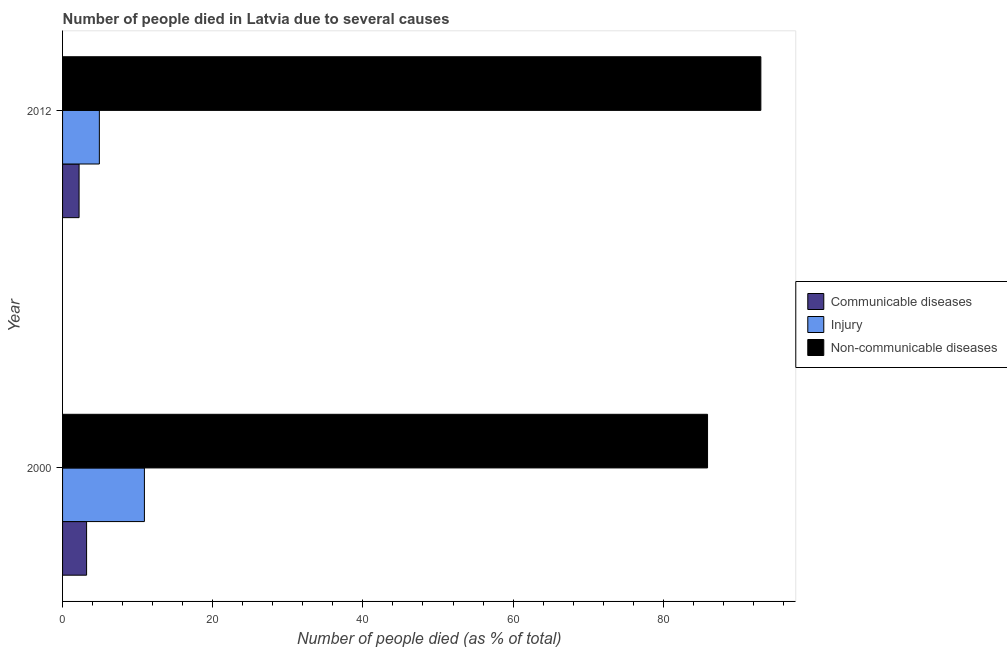Are the number of bars per tick equal to the number of legend labels?
Your answer should be compact. Yes. Are the number of bars on each tick of the Y-axis equal?
Keep it short and to the point. Yes. How many bars are there on the 1st tick from the top?
Your answer should be very brief. 3. In how many cases, is the number of bars for a given year not equal to the number of legend labels?
Provide a succinct answer. 0. What is the number of people who dies of non-communicable diseases in 2012?
Keep it short and to the point. 93. What is the total number of people who died of communicable diseases in the graph?
Provide a succinct answer. 5.4. What is the difference between the number of people who dies of non-communicable diseases in 2000 and the number of people who died of communicable diseases in 2012?
Provide a short and direct response. 83.7. What is the average number of people who dies of non-communicable diseases per year?
Your answer should be compact. 89.45. In the year 2012, what is the difference between the number of people who dies of non-communicable diseases and number of people who died of communicable diseases?
Offer a terse response. 90.8. What is the ratio of the number of people who dies of non-communicable diseases in 2000 to that in 2012?
Keep it short and to the point. 0.92. Is the difference between the number of people who died of communicable diseases in 2000 and 2012 greater than the difference between the number of people who died of injury in 2000 and 2012?
Your response must be concise. No. In how many years, is the number of people who died of communicable diseases greater than the average number of people who died of communicable diseases taken over all years?
Ensure brevity in your answer.  1. What does the 2nd bar from the top in 2000 represents?
Give a very brief answer. Injury. What does the 1st bar from the bottom in 2000 represents?
Offer a very short reply. Communicable diseases. How many years are there in the graph?
Make the answer very short. 2. What is the difference between two consecutive major ticks on the X-axis?
Your answer should be compact. 20. Are the values on the major ticks of X-axis written in scientific E-notation?
Ensure brevity in your answer.  No. Does the graph contain any zero values?
Provide a short and direct response. No. Does the graph contain grids?
Your response must be concise. No. How many legend labels are there?
Give a very brief answer. 3. What is the title of the graph?
Provide a succinct answer. Number of people died in Latvia due to several causes. Does "Czech Republic" appear as one of the legend labels in the graph?
Your answer should be compact. No. What is the label or title of the X-axis?
Offer a terse response. Number of people died (as % of total). What is the Number of people died (as % of total) in Communicable diseases in 2000?
Keep it short and to the point. 3.2. What is the Number of people died (as % of total) in Injury in 2000?
Your answer should be compact. 10.9. What is the Number of people died (as % of total) in Non-communicable diseases in 2000?
Offer a very short reply. 85.9. What is the Number of people died (as % of total) in Communicable diseases in 2012?
Make the answer very short. 2.2. What is the Number of people died (as % of total) in Injury in 2012?
Offer a very short reply. 4.9. What is the Number of people died (as % of total) in Non-communicable diseases in 2012?
Offer a terse response. 93. Across all years, what is the maximum Number of people died (as % of total) of Non-communicable diseases?
Your answer should be very brief. 93. Across all years, what is the minimum Number of people died (as % of total) in Non-communicable diseases?
Your response must be concise. 85.9. What is the total Number of people died (as % of total) of Communicable diseases in the graph?
Your answer should be compact. 5.4. What is the total Number of people died (as % of total) of Non-communicable diseases in the graph?
Provide a succinct answer. 178.9. What is the difference between the Number of people died (as % of total) of Communicable diseases in 2000 and that in 2012?
Offer a very short reply. 1. What is the difference between the Number of people died (as % of total) of Injury in 2000 and that in 2012?
Ensure brevity in your answer.  6. What is the difference between the Number of people died (as % of total) of Communicable diseases in 2000 and the Number of people died (as % of total) of Non-communicable diseases in 2012?
Your answer should be compact. -89.8. What is the difference between the Number of people died (as % of total) in Injury in 2000 and the Number of people died (as % of total) in Non-communicable diseases in 2012?
Offer a very short reply. -82.1. What is the average Number of people died (as % of total) of Communicable diseases per year?
Provide a succinct answer. 2.7. What is the average Number of people died (as % of total) in Injury per year?
Offer a terse response. 7.9. What is the average Number of people died (as % of total) of Non-communicable diseases per year?
Offer a very short reply. 89.45. In the year 2000, what is the difference between the Number of people died (as % of total) of Communicable diseases and Number of people died (as % of total) of Non-communicable diseases?
Provide a succinct answer. -82.7. In the year 2000, what is the difference between the Number of people died (as % of total) of Injury and Number of people died (as % of total) of Non-communicable diseases?
Provide a short and direct response. -75. In the year 2012, what is the difference between the Number of people died (as % of total) in Communicable diseases and Number of people died (as % of total) in Injury?
Your answer should be compact. -2.7. In the year 2012, what is the difference between the Number of people died (as % of total) in Communicable diseases and Number of people died (as % of total) in Non-communicable diseases?
Provide a succinct answer. -90.8. In the year 2012, what is the difference between the Number of people died (as % of total) of Injury and Number of people died (as % of total) of Non-communicable diseases?
Provide a succinct answer. -88.1. What is the ratio of the Number of people died (as % of total) in Communicable diseases in 2000 to that in 2012?
Provide a succinct answer. 1.45. What is the ratio of the Number of people died (as % of total) of Injury in 2000 to that in 2012?
Ensure brevity in your answer.  2.22. What is the ratio of the Number of people died (as % of total) of Non-communicable diseases in 2000 to that in 2012?
Provide a succinct answer. 0.92. What is the difference between the highest and the second highest Number of people died (as % of total) in Communicable diseases?
Make the answer very short. 1. What is the difference between the highest and the second highest Number of people died (as % of total) in Injury?
Offer a very short reply. 6. What is the difference between the highest and the second highest Number of people died (as % of total) of Non-communicable diseases?
Your answer should be compact. 7.1. 